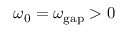Convert formula to latex. <formula><loc_0><loc_0><loc_500><loc_500>\omega _ { 0 } = \omega _ { g a p } > 0</formula> 